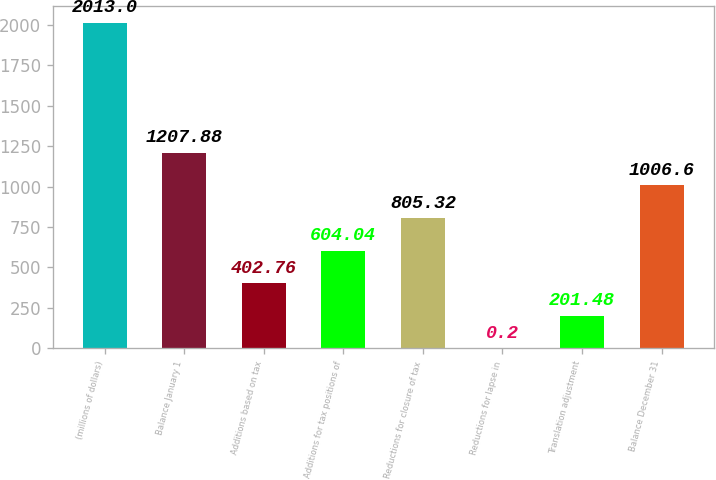Convert chart. <chart><loc_0><loc_0><loc_500><loc_500><bar_chart><fcel>(millions of dollars)<fcel>Balance January 1<fcel>Additions based on tax<fcel>Additions for tax positions of<fcel>Reductions for closure of tax<fcel>Reductions for lapse in<fcel>Translation adjustment<fcel>Balance December 31<nl><fcel>2013<fcel>1207.88<fcel>402.76<fcel>604.04<fcel>805.32<fcel>0.2<fcel>201.48<fcel>1006.6<nl></chart> 